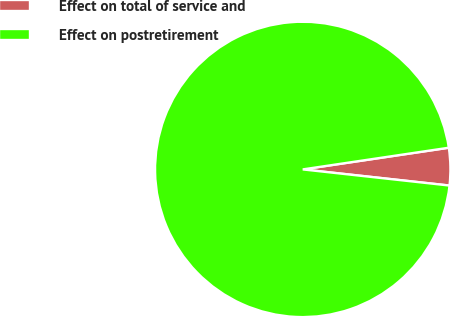Convert chart to OTSL. <chart><loc_0><loc_0><loc_500><loc_500><pie_chart><fcel>Effect on total of service and<fcel>Effect on postretirement<nl><fcel>4.09%<fcel>95.91%<nl></chart> 